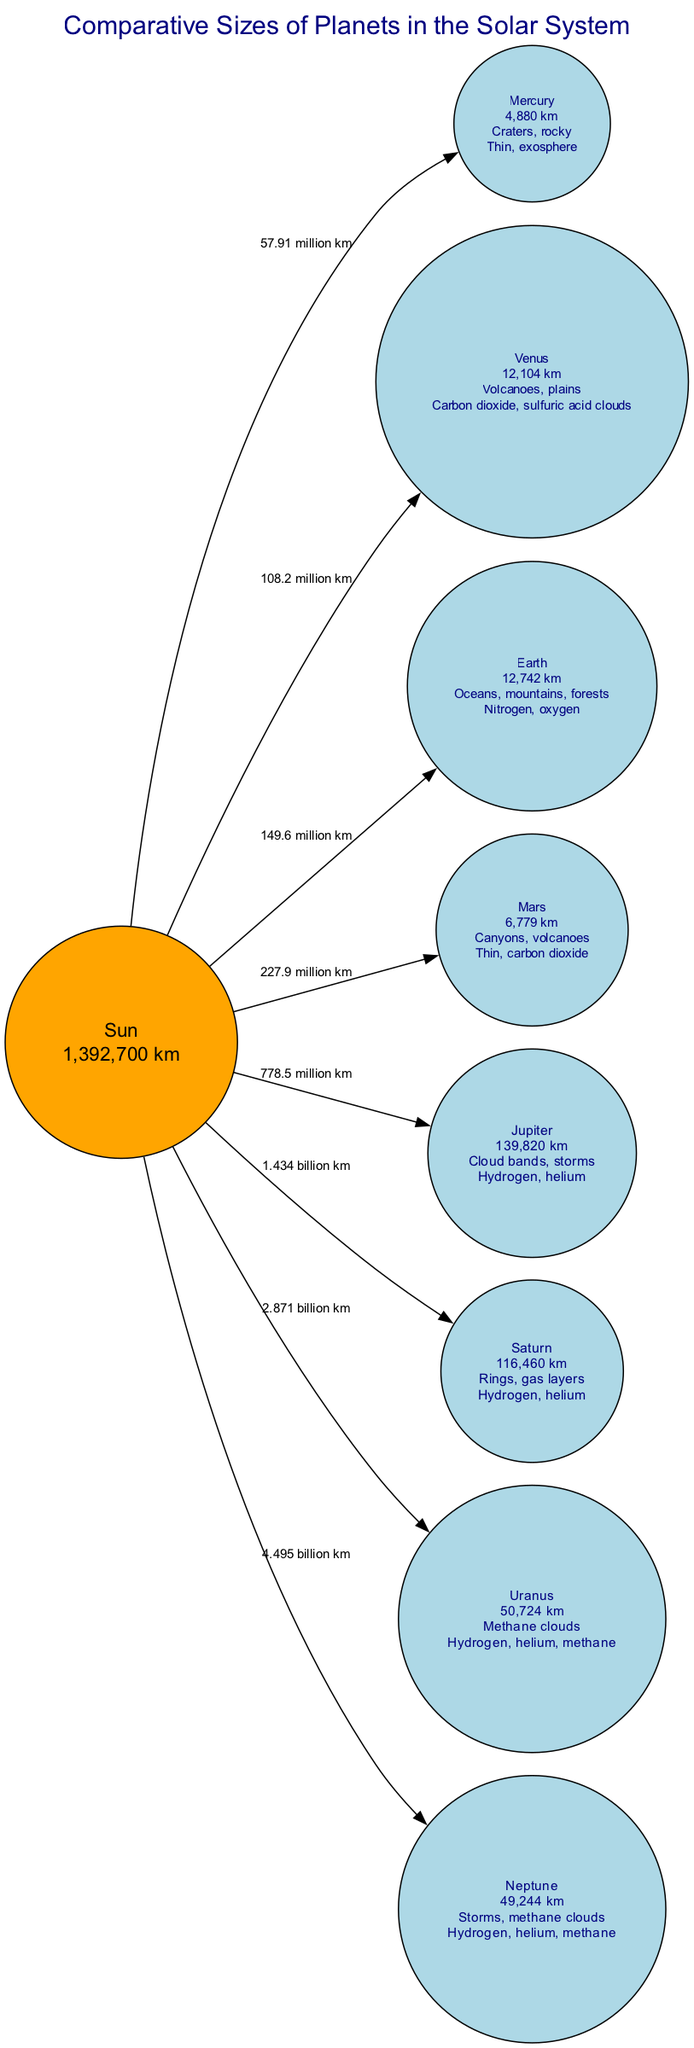What is the diameter of Jupiter? The diameter of Jupiter is listed as "139,820 km" in the diagram.
Answer: 139,820 km What features are found on Mars? The surface features of Mars include "Canyons, volcanoes" as mentioned in the node description.
Answer: Canyons, volcanoes How far is Earth from the Sun? The distance from the Sun to Earth is labeled as "149.6 million km" in the diagram.
Answer: 149.6 million km Which planet has the thickest atmosphere? The planet with the thickest atmosphere in the diagram is Venus, which has a "Carbon dioxide, sulfuric acid clouds" atmosphere.
Answer: Venus What is the primary composition of Neptune's atmosphere? The atmosphere of Neptune is composed mainly of "Hydrogen, helium, methane" as stated in its node description.
Answer: Hydrogen, helium, methane Which two planets are gas giants? Referring to the diagram, the two planets categorized as gas giants are Jupiter and Saturn.
Answer: Jupiter, Saturn How many planets are depicted in this diagram? The diagram displays a total of 8 planets along with the Sun.
Answer: 8 What is the diameter of Mercury compared to Earth? Mercury's diameter is "4,880 km," which is significantly smaller than Earth's diameter of "12,742 km." Thus, Mercury is the smallest planet.
Answer: 4,880 km Which planet has the most distinct surface features of rings? The planet that has distinct surface features of rings is Saturn, as highlighted in its node description.
Answer: Saturn What is the estimated distance from the Sun to Uranus? According to the diagram, the distance from the Sun to Uranus is "2.871 billion km."
Answer: 2.871 billion km 